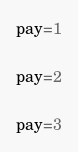Convert code to text. <code><loc_0><loc_0><loc_500><loc_500><_Python_>pay=1

pay=2

pay=3

</code> 